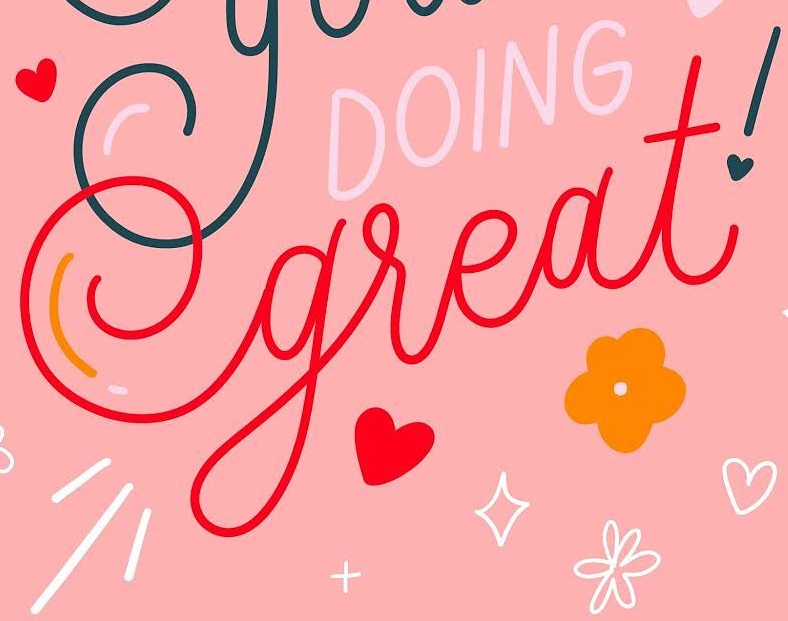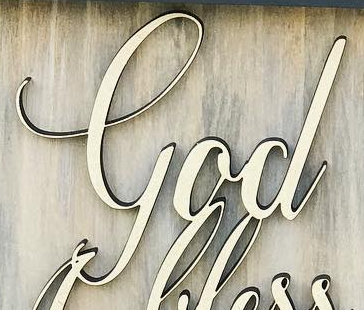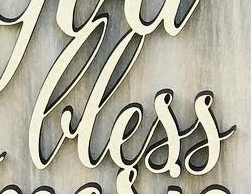What words are shown in these images in order, separated by a semicolon? great!; God; lless 